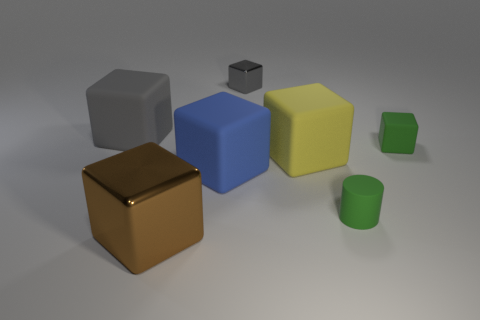Subtract all tiny metallic blocks. How many blocks are left? 5 Subtract all gray cubes. How many cubes are left? 4 Subtract 5 cubes. How many cubes are left? 1 Subtract all purple balls. How many yellow blocks are left? 1 Add 1 blue rubber things. How many objects exist? 8 Subtract 2 gray blocks. How many objects are left? 5 Subtract all cubes. How many objects are left? 1 Subtract all cyan blocks. Subtract all blue cylinders. How many blocks are left? 6 Subtract all big green metallic cylinders. Subtract all large gray rubber cubes. How many objects are left? 6 Add 1 large cubes. How many large cubes are left? 5 